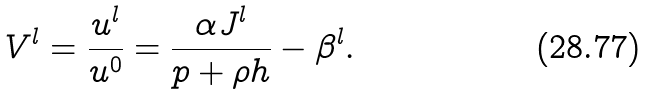<formula> <loc_0><loc_0><loc_500><loc_500>V ^ { l } = \frac { u ^ { l } } { u ^ { 0 } } = \frac { \alpha J ^ { l } } { p + \rho h } - \beta ^ { l } .</formula> 